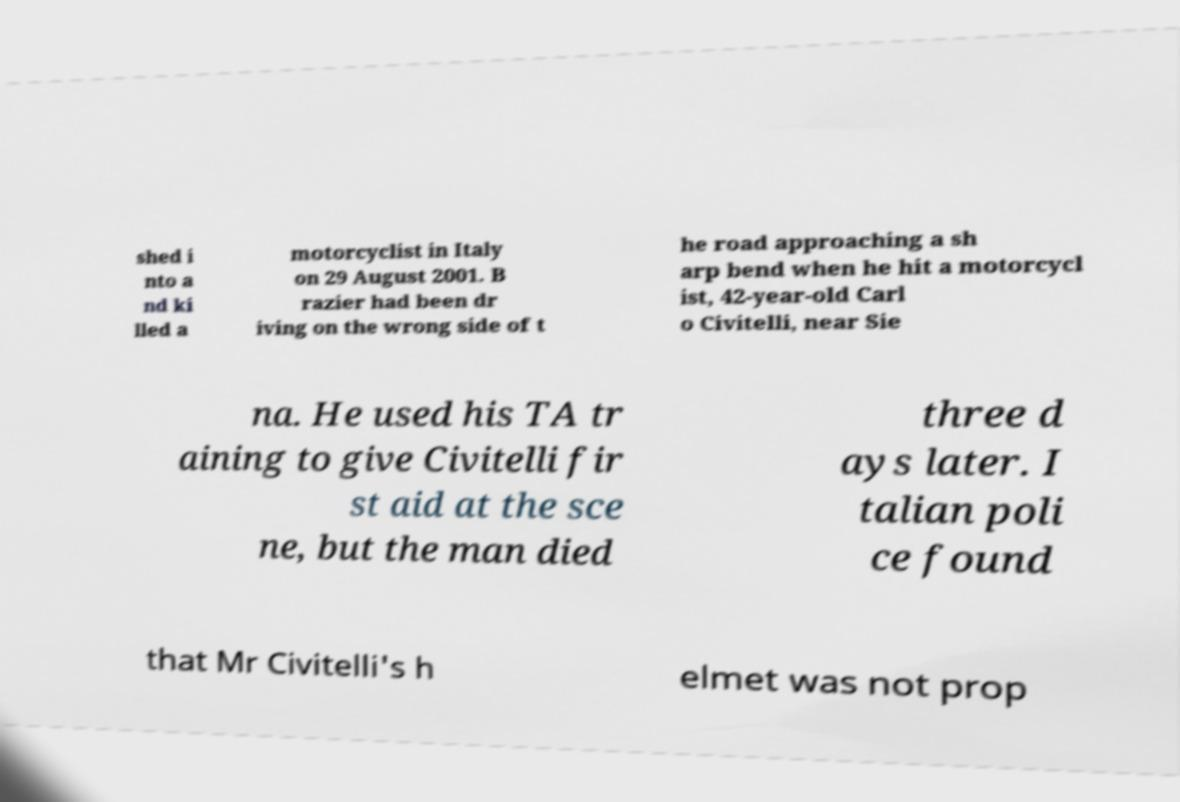Please identify and transcribe the text found in this image. shed i nto a nd ki lled a motorcyclist in Italy on 29 August 2001. B razier had been dr iving on the wrong side of t he road approaching a sh arp bend when he hit a motorcycl ist, 42-year-old Carl o Civitelli, near Sie na. He used his TA tr aining to give Civitelli fir st aid at the sce ne, but the man died three d ays later. I talian poli ce found that Mr Civitelli's h elmet was not prop 